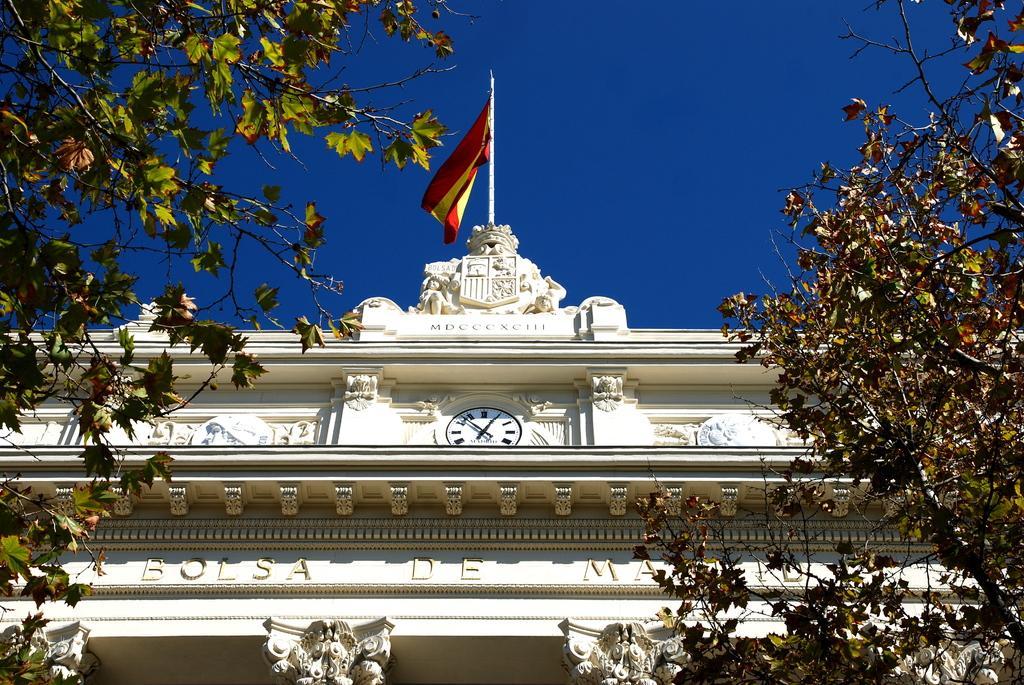In one or two sentences, can you explain what this image depicts? This image consists of a building in the middle. There is a flag at the top. There is sky at the top. There are trees on the left side and right side. There is a clock in the middle. 